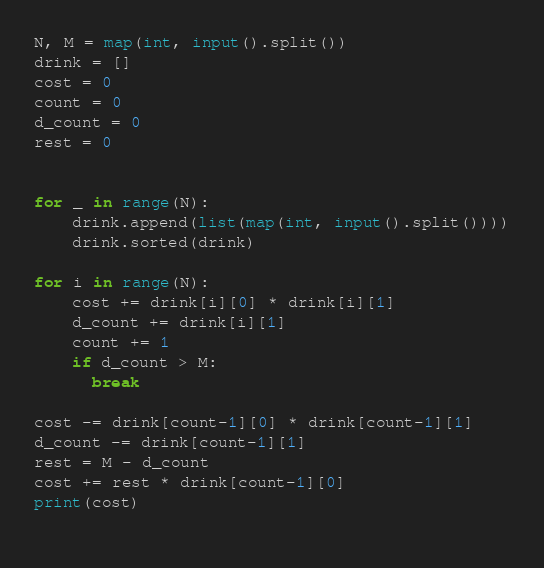Convert code to text. <code><loc_0><loc_0><loc_500><loc_500><_Python_>N, M = map(int, input().split())
drink = []
cost = 0
count = 0
d_count = 0
rest = 0


for _ in range(N):
    drink.append(list(map(int, input().split())))
    drink.sorted(drink)

for i in range(N):
    cost += drink[i][0] * drink[i][1]
    d_count += drink[i][1]
    count += 1
    if d_count > M:
      break
      
cost -= drink[count-1][0] * drink[count-1][1]
d_count -= drink[count-1][1]
rest = M - d_count
cost += rest * drink[count-1][0]
print(cost)
    </code> 